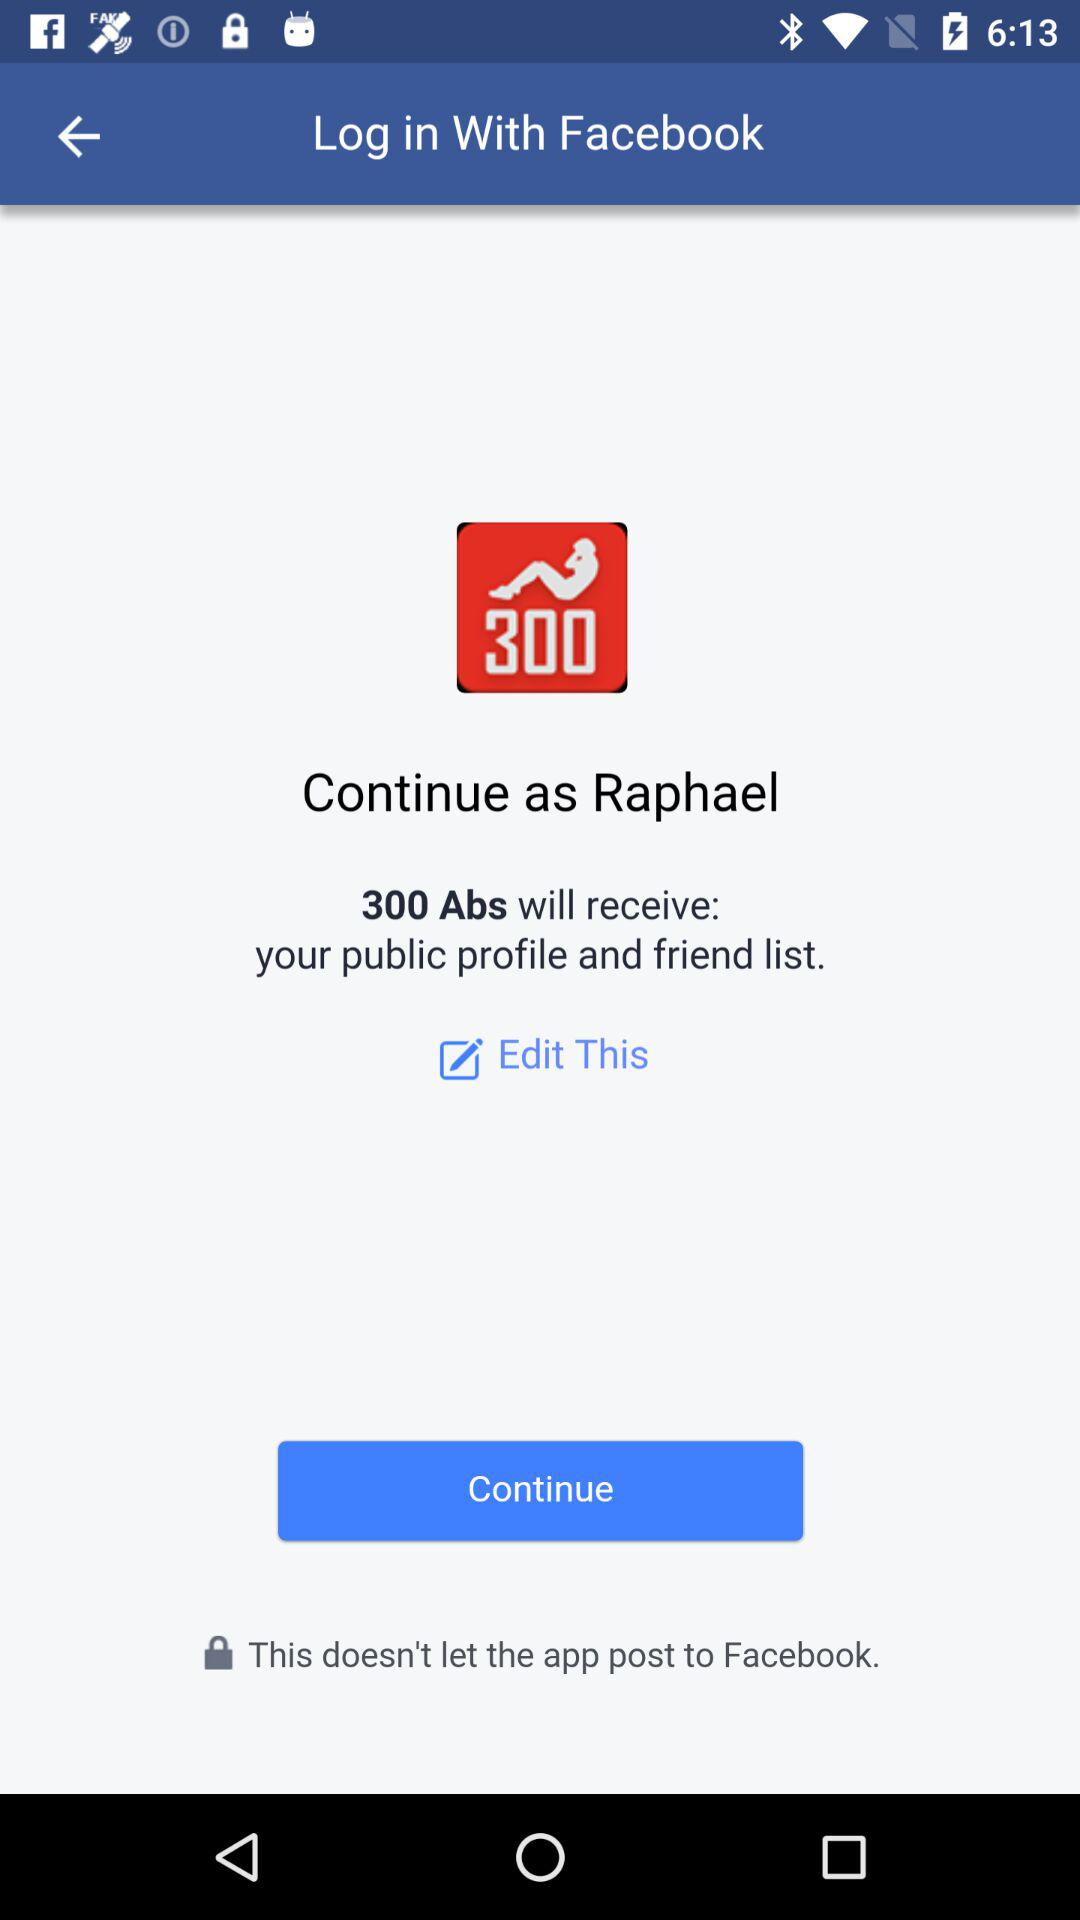What is the user name? The user name is Raphael. 